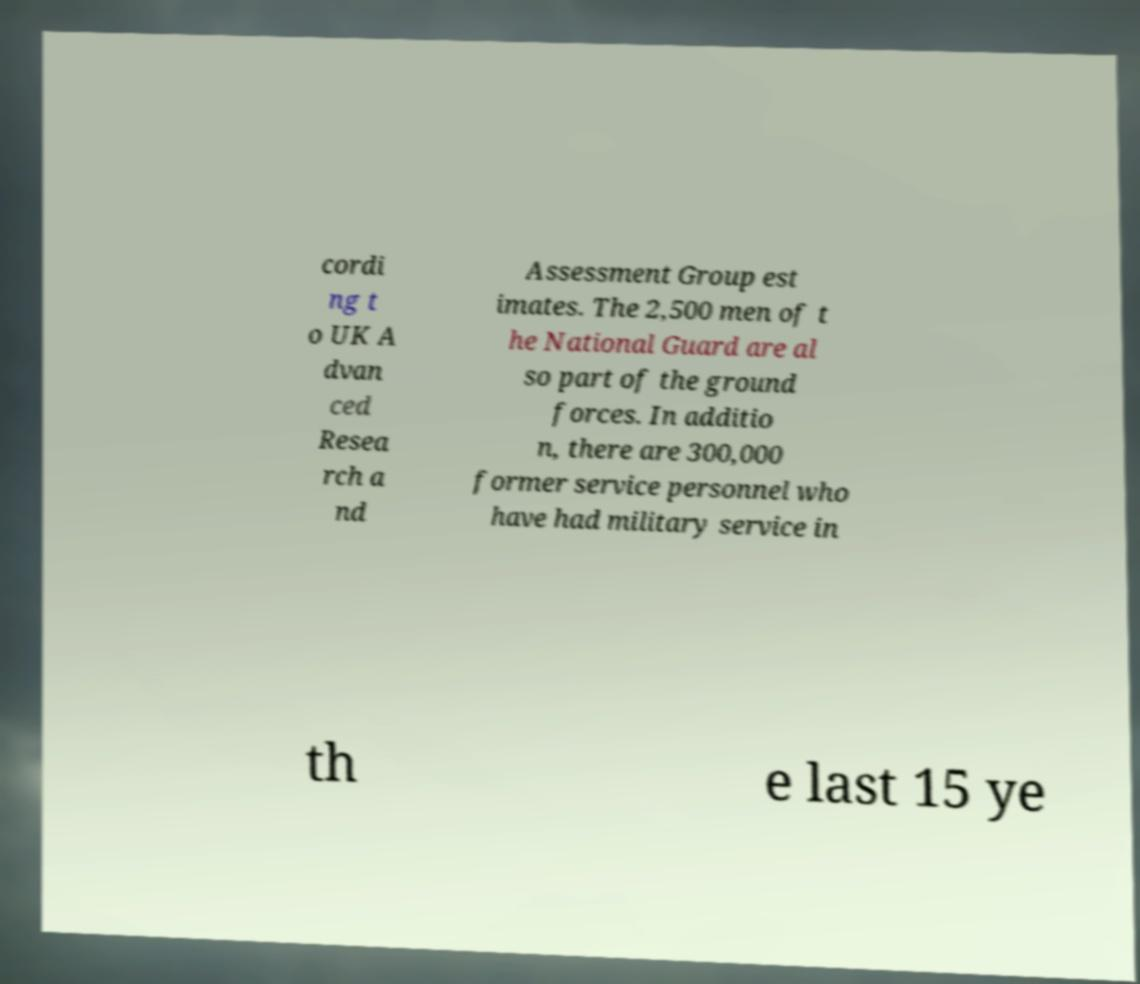Could you extract and type out the text from this image? cordi ng t o UK A dvan ced Resea rch a nd Assessment Group est imates. The 2,500 men of t he National Guard are al so part of the ground forces. In additio n, there are 300,000 former service personnel who have had military service in th e last 15 ye 